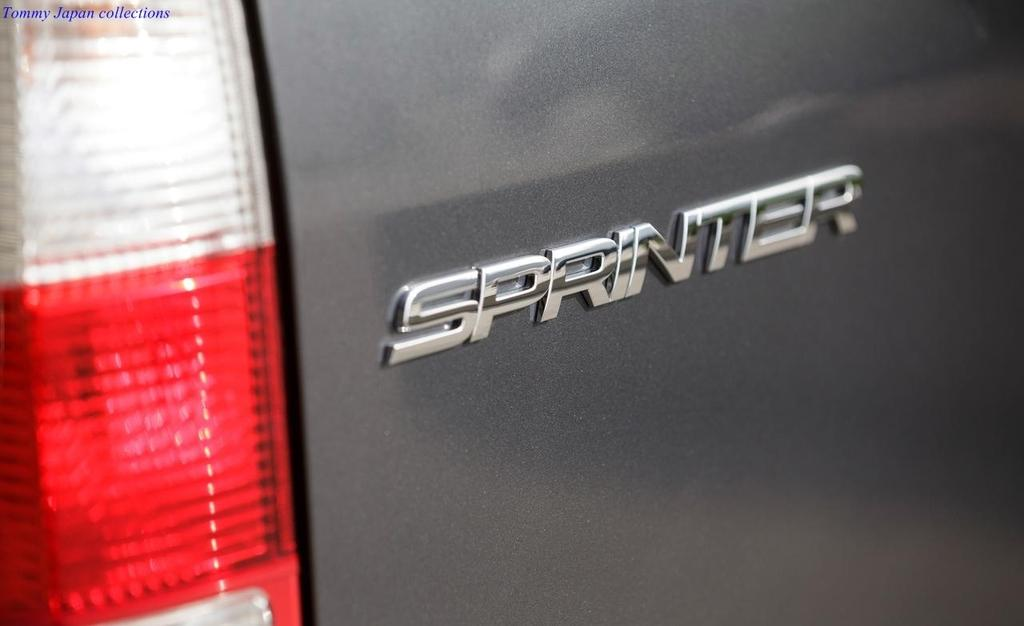What type of vehicle is in the image? There is a car in the image. What color is the car? The car is gray in color. What is written on the car? The car has "Sprinter" written on it. What traffic control device is visible in the image? There is a stoplight visible in the image. Can you see your sister in the image? There is no mention of a sister or any person in the image, so we cannot see your sister in the image. 